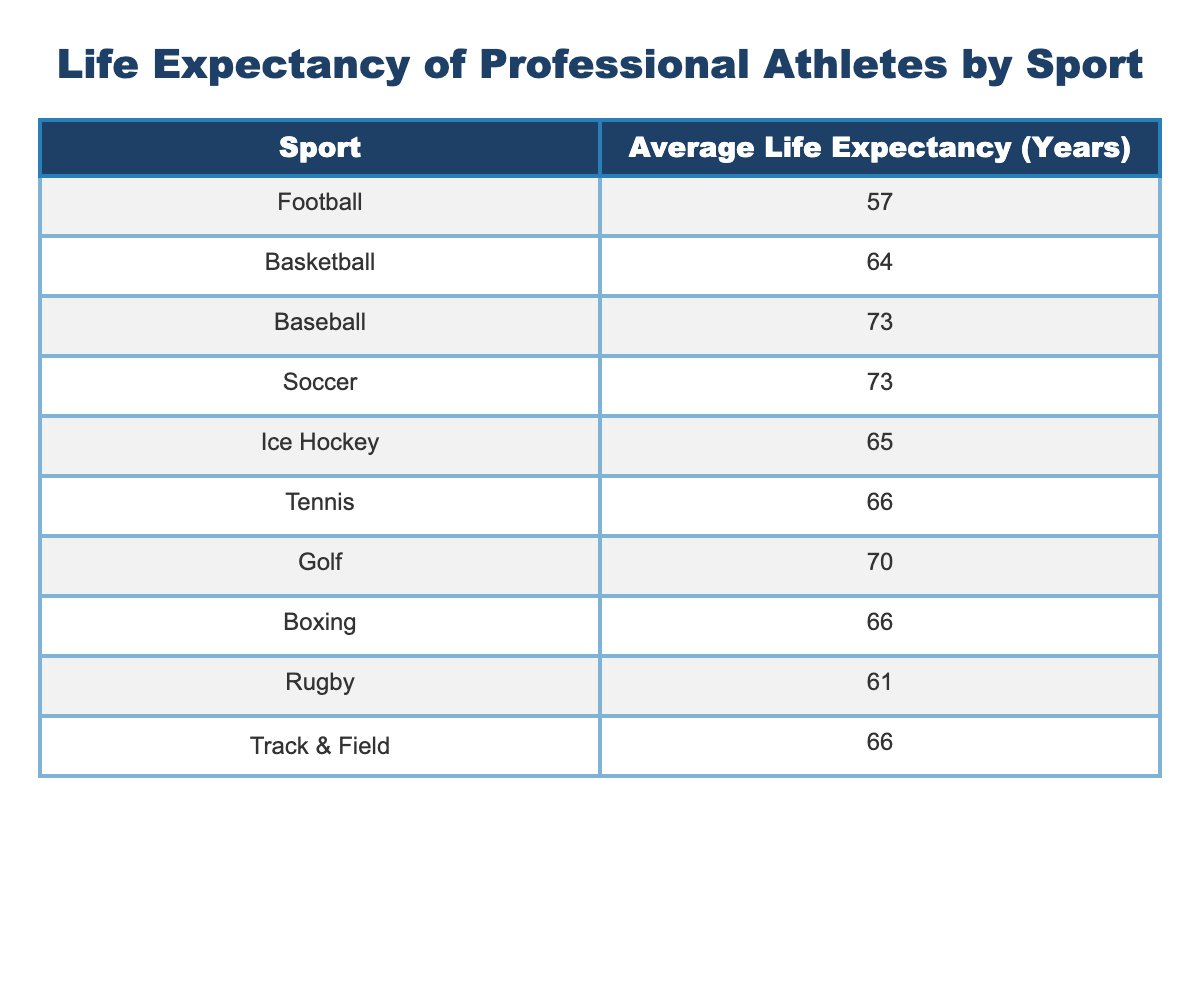What is the average life expectancy for soccer players? The table shows that the average life expectancy for soccer players is listed as 73 years.
Answer: 73 Which sport has the lowest average life expectancy? According to the table, football has the lowest average life expectancy at 57 years.
Answer: 57 Is the average life expectancy for tennis players greater than that of ice hockey players? Looking at the table, tennis players have an average life expectancy of 66 years, while ice hockey players have an average of 65 years. Since 66 is greater than 65, the statement is true.
Answer: Yes What is the difference in average life expectancy between baseball and football players? Baseball players have an average life expectancy of 73 years while football players have an average of 57 years. The difference is calculated as 73 - 57, which equals 16 years.
Answer: 16 What is the average life expectancy of the top four sports: football, basketball, baseball, and soccer? First, we list their life expectancies: football (57), basketball (64), baseball (73), and soccer (73). Adding them gives 57 + 64 + 73 + 73 = 267. There are 4 sports, so the average is 267 / 4 = 66.75.
Answer: 66.75 True or False: The average life expectancy for golfers is higher than that of basketball players. The table states that golfers have an average life expectancy of 70 years and basketball players have 64 years. Since 70 is greater than 64, the statement is true.
Answer: True Which two sports have the same average life expectancy? From the table, both baseball and soccer have an average life expectancy of 73 years.
Answer: Baseball and Soccer If you combined the average life expectancies of track & field and boxing, what would the total be? The average life expectancy for track & field is 66 years, and for boxing, it is also 66 years. Adding them together gives us 66 + 66 = 132 years.
Answer: 132 Which sport's average life expectancy is closest to the overall average of these sports? To find the overall average, we sum the average life expectancies: 57 + 64 + 73 + 73 + 65 + 66 + 70 + 66 + 61 + 66 =  66.5. The sport closest to this average is tennis at 66 years.
Answer: Tennis 